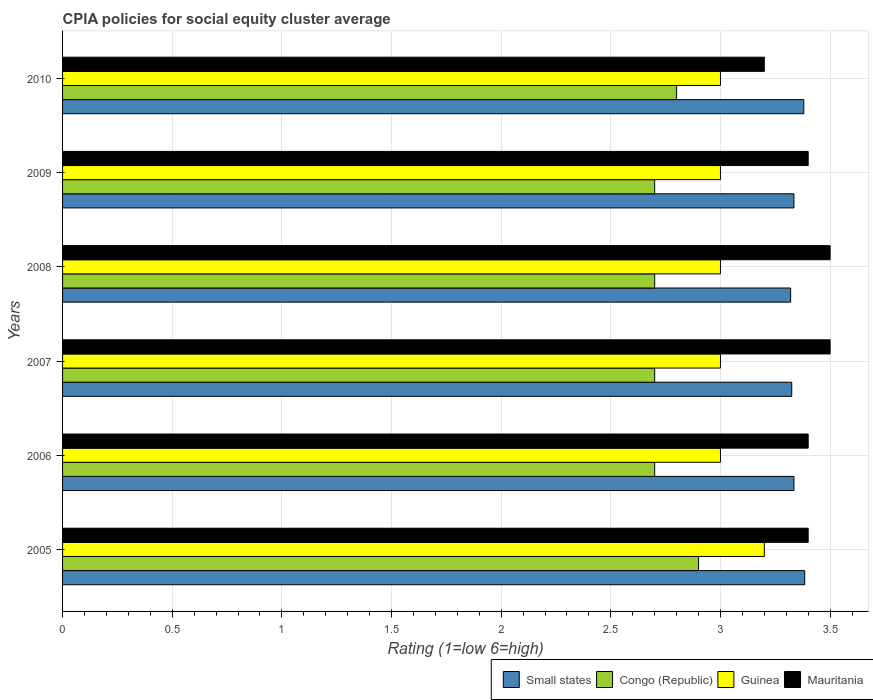How many groups of bars are there?
Give a very brief answer. 6. Are the number of bars per tick equal to the number of legend labels?
Keep it short and to the point. Yes. Are the number of bars on each tick of the Y-axis equal?
Provide a succinct answer. Yes. What is the CPIA rating in Guinea in 2006?
Provide a succinct answer. 3. Across all years, what is the maximum CPIA rating in Small states?
Offer a very short reply. 3.38. Across all years, what is the minimum CPIA rating in Small states?
Your answer should be compact. 3.32. In which year was the CPIA rating in Small states maximum?
Your answer should be compact. 2005. What is the total CPIA rating in Small states in the graph?
Your response must be concise. 20.08. What is the difference between the CPIA rating in Guinea in 2005 and that in 2006?
Make the answer very short. 0.2. What is the average CPIA rating in Congo (Republic) per year?
Keep it short and to the point. 2.75. In the year 2009, what is the difference between the CPIA rating in Guinea and CPIA rating in Congo (Republic)?
Provide a short and direct response. 0.3. What is the ratio of the CPIA rating in Small states in 2005 to that in 2010?
Offer a very short reply. 1. Is the CPIA rating in Small states in 2006 less than that in 2010?
Your response must be concise. Yes. What is the difference between the highest and the second highest CPIA rating in Mauritania?
Keep it short and to the point. 0. What is the difference between the highest and the lowest CPIA rating in Congo (Republic)?
Offer a terse response. 0.2. In how many years, is the CPIA rating in Congo (Republic) greater than the average CPIA rating in Congo (Republic) taken over all years?
Offer a terse response. 2. Is it the case that in every year, the sum of the CPIA rating in Small states and CPIA rating in Guinea is greater than the sum of CPIA rating in Mauritania and CPIA rating in Congo (Republic)?
Provide a succinct answer. Yes. What does the 2nd bar from the top in 2005 represents?
Make the answer very short. Guinea. What does the 3rd bar from the bottom in 2007 represents?
Ensure brevity in your answer.  Guinea. Are the values on the major ticks of X-axis written in scientific E-notation?
Offer a very short reply. No. Does the graph contain any zero values?
Make the answer very short. No. Does the graph contain grids?
Provide a succinct answer. Yes. Where does the legend appear in the graph?
Provide a short and direct response. Bottom right. How are the legend labels stacked?
Make the answer very short. Horizontal. What is the title of the graph?
Your response must be concise. CPIA policies for social equity cluster average. Does "Russian Federation" appear as one of the legend labels in the graph?
Provide a short and direct response. No. What is the label or title of the X-axis?
Keep it short and to the point. Rating (1=low 6=high). What is the Rating (1=low 6=high) of Small states in 2005?
Your answer should be very brief. 3.38. What is the Rating (1=low 6=high) in Congo (Republic) in 2005?
Provide a succinct answer. 2.9. What is the Rating (1=low 6=high) in Guinea in 2005?
Make the answer very short. 3.2. What is the Rating (1=low 6=high) of Mauritania in 2005?
Your answer should be very brief. 3.4. What is the Rating (1=low 6=high) of Small states in 2006?
Keep it short and to the point. 3.33. What is the Rating (1=low 6=high) in Guinea in 2006?
Offer a very short reply. 3. What is the Rating (1=low 6=high) in Small states in 2007?
Offer a very short reply. 3.33. What is the Rating (1=low 6=high) in Mauritania in 2007?
Your answer should be very brief. 3.5. What is the Rating (1=low 6=high) of Small states in 2008?
Offer a terse response. 3.32. What is the Rating (1=low 6=high) of Congo (Republic) in 2008?
Offer a very short reply. 2.7. What is the Rating (1=low 6=high) in Guinea in 2008?
Provide a short and direct response. 3. What is the Rating (1=low 6=high) of Mauritania in 2008?
Give a very brief answer. 3.5. What is the Rating (1=low 6=high) in Small states in 2009?
Provide a short and direct response. 3.33. What is the Rating (1=low 6=high) of Congo (Republic) in 2009?
Offer a very short reply. 2.7. What is the Rating (1=low 6=high) of Guinea in 2009?
Provide a succinct answer. 3. What is the Rating (1=low 6=high) of Mauritania in 2009?
Give a very brief answer. 3.4. What is the Rating (1=low 6=high) of Small states in 2010?
Ensure brevity in your answer.  3.38. Across all years, what is the maximum Rating (1=low 6=high) in Small states?
Your response must be concise. 3.38. Across all years, what is the minimum Rating (1=low 6=high) of Small states?
Your answer should be compact. 3.32. Across all years, what is the minimum Rating (1=low 6=high) in Guinea?
Give a very brief answer. 3. What is the total Rating (1=low 6=high) of Small states in the graph?
Your answer should be very brief. 20.08. What is the total Rating (1=low 6=high) of Congo (Republic) in the graph?
Provide a succinct answer. 16.5. What is the total Rating (1=low 6=high) in Mauritania in the graph?
Provide a short and direct response. 20.4. What is the difference between the Rating (1=low 6=high) in Small states in 2005 and that in 2006?
Offer a very short reply. 0.05. What is the difference between the Rating (1=low 6=high) in Congo (Republic) in 2005 and that in 2006?
Your answer should be very brief. 0.2. What is the difference between the Rating (1=low 6=high) of Small states in 2005 and that in 2007?
Ensure brevity in your answer.  0.06. What is the difference between the Rating (1=low 6=high) in Guinea in 2005 and that in 2007?
Your answer should be compact. 0.2. What is the difference between the Rating (1=low 6=high) of Mauritania in 2005 and that in 2007?
Your response must be concise. -0.1. What is the difference between the Rating (1=low 6=high) in Small states in 2005 and that in 2008?
Keep it short and to the point. 0.06. What is the difference between the Rating (1=low 6=high) of Congo (Republic) in 2005 and that in 2008?
Your answer should be compact. 0.2. What is the difference between the Rating (1=low 6=high) of Mauritania in 2005 and that in 2008?
Provide a succinct answer. -0.1. What is the difference between the Rating (1=low 6=high) in Small states in 2005 and that in 2009?
Make the answer very short. 0.05. What is the difference between the Rating (1=low 6=high) of Congo (Republic) in 2005 and that in 2009?
Your answer should be compact. 0.2. What is the difference between the Rating (1=low 6=high) of Mauritania in 2005 and that in 2009?
Keep it short and to the point. 0. What is the difference between the Rating (1=low 6=high) of Small states in 2005 and that in 2010?
Give a very brief answer. 0. What is the difference between the Rating (1=low 6=high) of Guinea in 2005 and that in 2010?
Keep it short and to the point. 0.2. What is the difference between the Rating (1=low 6=high) in Mauritania in 2005 and that in 2010?
Offer a very short reply. 0.2. What is the difference between the Rating (1=low 6=high) of Small states in 2006 and that in 2007?
Offer a very short reply. 0.01. What is the difference between the Rating (1=low 6=high) in Small states in 2006 and that in 2008?
Keep it short and to the point. 0.01. What is the difference between the Rating (1=low 6=high) in Guinea in 2006 and that in 2008?
Keep it short and to the point. 0. What is the difference between the Rating (1=low 6=high) of Small states in 2006 and that in 2009?
Ensure brevity in your answer.  0. What is the difference between the Rating (1=low 6=high) in Congo (Republic) in 2006 and that in 2009?
Make the answer very short. 0. What is the difference between the Rating (1=low 6=high) of Mauritania in 2006 and that in 2009?
Your response must be concise. 0. What is the difference between the Rating (1=low 6=high) in Small states in 2006 and that in 2010?
Your answer should be very brief. -0.04. What is the difference between the Rating (1=low 6=high) of Congo (Republic) in 2006 and that in 2010?
Ensure brevity in your answer.  -0.1. What is the difference between the Rating (1=low 6=high) in Guinea in 2006 and that in 2010?
Your answer should be compact. 0. What is the difference between the Rating (1=low 6=high) in Small states in 2007 and that in 2008?
Your answer should be very brief. 0.01. What is the difference between the Rating (1=low 6=high) in Mauritania in 2007 and that in 2008?
Your answer should be compact. 0. What is the difference between the Rating (1=low 6=high) of Small states in 2007 and that in 2009?
Provide a short and direct response. -0.01. What is the difference between the Rating (1=low 6=high) of Congo (Republic) in 2007 and that in 2009?
Your answer should be very brief. 0. What is the difference between the Rating (1=low 6=high) in Mauritania in 2007 and that in 2009?
Provide a short and direct response. 0.1. What is the difference between the Rating (1=low 6=high) of Small states in 2007 and that in 2010?
Ensure brevity in your answer.  -0.06. What is the difference between the Rating (1=low 6=high) in Congo (Republic) in 2007 and that in 2010?
Your response must be concise. -0.1. What is the difference between the Rating (1=low 6=high) of Guinea in 2007 and that in 2010?
Offer a very short reply. 0. What is the difference between the Rating (1=low 6=high) in Mauritania in 2007 and that in 2010?
Offer a terse response. 0.3. What is the difference between the Rating (1=low 6=high) of Small states in 2008 and that in 2009?
Ensure brevity in your answer.  -0.01. What is the difference between the Rating (1=low 6=high) of Congo (Republic) in 2008 and that in 2009?
Offer a very short reply. 0. What is the difference between the Rating (1=low 6=high) of Mauritania in 2008 and that in 2009?
Provide a succinct answer. 0.1. What is the difference between the Rating (1=low 6=high) in Small states in 2008 and that in 2010?
Provide a short and direct response. -0.06. What is the difference between the Rating (1=low 6=high) in Congo (Republic) in 2008 and that in 2010?
Provide a succinct answer. -0.1. What is the difference between the Rating (1=low 6=high) in Guinea in 2008 and that in 2010?
Make the answer very short. 0. What is the difference between the Rating (1=low 6=high) of Mauritania in 2008 and that in 2010?
Offer a terse response. 0.3. What is the difference between the Rating (1=low 6=high) in Small states in 2009 and that in 2010?
Give a very brief answer. -0.04. What is the difference between the Rating (1=low 6=high) of Congo (Republic) in 2009 and that in 2010?
Provide a succinct answer. -0.1. What is the difference between the Rating (1=low 6=high) in Guinea in 2009 and that in 2010?
Your answer should be compact. 0. What is the difference between the Rating (1=low 6=high) of Small states in 2005 and the Rating (1=low 6=high) of Congo (Republic) in 2006?
Ensure brevity in your answer.  0.68. What is the difference between the Rating (1=low 6=high) of Small states in 2005 and the Rating (1=low 6=high) of Guinea in 2006?
Your answer should be compact. 0.38. What is the difference between the Rating (1=low 6=high) of Small states in 2005 and the Rating (1=low 6=high) of Mauritania in 2006?
Offer a very short reply. -0.02. What is the difference between the Rating (1=low 6=high) in Congo (Republic) in 2005 and the Rating (1=low 6=high) in Guinea in 2006?
Your response must be concise. -0.1. What is the difference between the Rating (1=low 6=high) in Guinea in 2005 and the Rating (1=low 6=high) in Mauritania in 2006?
Give a very brief answer. -0.2. What is the difference between the Rating (1=low 6=high) of Small states in 2005 and the Rating (1=low 6=high) of Congo (Republic) in 2007?
Make the answer very short. 0.68. What is the difference between the Rating (1=low 6=high) of Small states in 2005 and the Rating (1=low 6=high) of Guinea in 2007?
Provide a short and direct response. 0.38. What is the difference between the Rating (1=low 6=high) in Small states in 2005 and the Rating (1=low 6=high) in Mauritania in 2007?
Offer a very short reply. -0.12. What is the difference between the Rating (1=low 6=high) in Congo (Republic) in 2005 and the Rating (1=low 6=high) in Guinea in 2007?
Give a very brief answer. -0.1. What is the difference between the Rating (1=low 6=high) of Guinea in 2005 and the Rating (1=low 6=high) of Mauritania in 2007?
Offer a very short reply. -0.3. What is the difference between the Rating (1=low 6=high) in Small states in 2005 and the Rating (1=low 6=high) in Congo (Republic) in 2008?
Offer a very short reply. 0.68. What is the difference between the Rating (1=low 6=high) of Small states in 2005 and the Rating (1=low 6=high) of Guinea in 2008?
Make the answer very short. 0.38. What is the difference between the Rating (1=low 6=high) of Small states in 2005 and the Rating (1=low 6=high) of Mauritania in 2008?
Ensure brevity in your answer.  -0.12. What is the difference between the Rating (1=low 6=high) in Congo (Republic) in 2005 and the Rating (1=low 6=high) in Guinea in 2008?
Your answer should be compact. -0.1. What is the difference between the Rating (1=low 6=high) of Guinea in 2005 and the Rating (1=low 6=high) of Mauritania in 2008?
Ensure brevity in your answer.  -0.3. What is the difference between the Rating (1=low 6=high) of Small states in 2005 and the Rating (1=low 6=high) of Congo (Republic) in 2009?
Your answer should be very brief. 0.68. What is the difference between the Rating (1=low 6=high) of Small states in 2005 and the Rating (1=low 6=high) of Guinea in 2009?
Your answer should be compact. 0.38. What is the difference between the Rating (1=low 6=high) of Small states in 2005 and the Rating (1=low 6=high) of Mauritania in 2009?
Your answer should be very brief. -0.02. What is the difference between the Rating (1=low 6=high) in Congo (Republic) in 2005 and the Rating (1=low 6=high) in Mauritania in 2009?
Provide a succinct answer. -0.5. What is the difference between the Rating (1=low 6=high) of Small states in 2005 and the Rating (1=low 6=high) of Congo (Republic) in 2010?
Your answer should be compact. 0.58. What is the difference between the Rating (1=low 6=high) of Small states in 2005 and the Rating (1=low 6=high) of Guinea in 2010?
Your answer should be compact. 0.38. What is the difference between the Rating (1=low 6=high) of Small states in 2005 and the Rating (1=low 6=high) of Mauritania in 2010?
Offer a terse response. 0.18. What is the difference between the Rating (1=low 6=high) of Congo (Republic) in 2005 and the Rating (1=low 6=high) of Guinea in 2010?
Your answer should be very brief. -0.1. What is the difference between the Rating (1=low 6=high) of Small states in 2006 and the Rating (1=low 6=high) of Congo (Republic) in 2007?
Make the answer very short. 0.64. What is the difference between the Rating (1=low 6=high) of Small states in 2006 and the Rating (1=low 6=high) of Guinea in 2007?
Ensure brevity in your answer.  0.34. What is the difference between the Rating (1=low 6=high) in Small states in 2006 and the Rating (1=low 6=high) in Mauritania in 2007?
Your answer should be compact. -0.17. What is the difference between the Rating (1=low 6=high) of Congo (Republic) in 2006 and the Rating (1=low 6=high) of Guinea in 2007?
Provide a short and direct response. -0.3. What is the difference between the Rating (1=low 6=high) of Congo (Republic) in 2006 and the Rating (1=low 6=high) of Mauritania in 2007?
Offer a terse response. -0.8. What is the difference between the Rating (1=low 6=high) of Small states in 2006 and the Rating (1=low 6=high) of Congo (Republic) in 2008?
Offer a terse response. 0.64. What is the difference between the Rating (1=low 6=high) of Small states in 2006 and the Rating (1=low 6=high) of Guinea in 2008?
Offer a terse response. 0.34. What is the difference between the Rating (1=low 6=high) of Small states in 2006 and the Rating (1=low 6=high) of Mauritania in 2008?
Your answer should be compact. -0.17. What is the difference between the Rating (1=low 6=high) of Congo (Republic) in 2006 and the Rating (1=low 6=high) of Mauritania in 2008?
Keep it short and to the point. -0.8. What is the difference between the Rating (1=low 6=high) of Guinea in 2006 and the Rating (1=low 6=high) of Mauritania in 2008?
Give a very brief answer. -0.5. What is the difference between the Rating (1=low 6=high) in Small states in 2006 and the Rating (1=low 6=high) in Congo (Republic) in 2009?
Ensure brevity in your answer.  0.64. What is the difference between the Rating (1=low 6=high) in Small states in 2006 and the Rating (1=low 6=high) in Guinea in 2009?
Provide a short and direct response. 0.34. What is the difference between the Rating (1=low 6=high) in Small states in 2006 and the Rating (1=low 6=high) in Mauritania in 2009?
Offer a terse response. -0.07. What is the difference between the Rating (1=low 6=high) of Congo (Republic) in 2006 and the Rating (1=low 6=high) of Mauritania in 2009?
Give a very brief answer. -0.7. What is the difference between the Rating (1=low 6=high) in Guinea in 2006 and the Rating (1=low 6=high) in Mauritania in 2009?
Your answer should be very brief. -0.4. What is the difference between the Rating (1=low 6=high) of Small states in 2006 and the Rating (1=low 6=high) of Congo (Republic) in 2010?
Keep it short and to the point. 0.54. What is the difference between the Rating (1=low 6=high) of Small states in 2006 and the Rating (1=low 6=high) of Guinea in 2010?
Provide a succinct answer. 0.34. What is the difference between the Rating (1=low 6=high) of Small states in 2006 and the Rating (1=low 6=high) of Mauritania in 2010?
Ensure brevity in your answer.  0.14. What is the difference between the Rating (1=low 6=high) in Congo (Republic) in 2006 and the Rating (1=low 6=high) in Guinea in 2010?
Make the answer very short. -0.3. What is the difference between the Rating (1=low 6=high) of Guinea in 2006 and the Rating (1=low 6=high) of Mauritania in 2010?
Provide a succinct answer. -0.2. What is the difference between the Rating (1=low 6=high) of Small states in 2007 and the Rating (1=low 6=high) of Congo (Republic) in 2008?
Offer a very short reply. 0.62. What is the difference between the Rating (1=low 6=high) in Small states in 2007 and the Rating (1=low 6=high) in Guinea in 2008?
Provide a succinct answer. 0.33. What is the difference between the Rating (1=low 6=high) of Small states in 2007 and the Rating (1=low 6=high) of Mauritania in 2008?
Give a very brief answer. -0.17. What is the difference between the Rating (1=low 6=high) of Congo (Republic) in 2007 and the Rating (1=low 6=high) of Guinea in 2008?
Make the answer very short. -0.3. What is the difference between the Rating (1=low 6=high) in Small states in 2007 and the Rating (1=low 6=high) in Congo (Republic) in 2009?
Your answer should be compact. 0.62. What is the difference between the Rating (1=low 6=high) of Small states in 2007 and the Rating (1=low 6=high) of Guinea in 2009?
Your response must be concise. 0.33. What is the difference between the Rating (1=low 6=high) of Small states in 2007 and the Rating (1=low 6=high) of Mauritania in 2009?
Make the answer very short. -0.07. What is the difference between the Rating (1=low 6=high) in Congo (Republic) in 2007 and the Rating (1=low 6=high) in Guinea in 2009?
Give a very brief answer. -0.3. What is the difference between the Rating (1=low 6=high) of Small states in 2007 and the Rating (1=low 6=high) of Congo (Republic) in 2010?
Your response must be concise. 0.53. What is the difference between the Rating (1=low 6=high) in Small states in 2007 and the Rating (1=low 6=high) in Guinea in 2010?
Offer a very short reply. 0.33. What is the difference between the Rating (1=low 6=high) of Small states in 2007 and the Rating (1=low 6=high) of Mauritania in 2010?
Offer a very short reply. 0.12. What is the difference between the Rating (1=low 6=high) in Congo (Republic) in 2007 and the Rating (1=low 6=high) in Guinea in 2010?
Provide a succinct answer. -0.3. What is the difference between the Rating (1=low 6=high) in Guinea in 2007 and the Rating (1=low 6=high) in Mauritania in 2010?
Provide a succinct answer. -0.2. What is the difference between the Rating (1=low 6=high) in Small states in 2008 and the Rating (1=low 6=high) in Congo (Republic) in 2009?
Make the answer very short. 0.62. What is the difference between the Rating (1=low 6=high) in Small states in 2008 and the Rating (1=low 6=high) in Guinea in 2009?
Provide a short and direct response. 0.32. What is the difference between the Rating (1=low 6=high) of Small states in 2008 and the Rating (1=low 6=high) of Mauritania in 2009?
Provide a short and direct response. -0.08. What is the difference between the Rating (1=low 6=high) of Congo (Republic) in 2008 and the Rating (1=low 6=high) of Guinea in 2009?
Make the answer very short. -0.3. What is the difference between the Rating (1=low 6=high) of Congo (Republic) in 2008 and the Rating (1=low 6=high) of Mauritania in 2009?
Make the answer very short. -0.7. What is the difference between the Rating (1=low 6=high) of Small states in 2008 and the Rating (1=low 6=high) of Congo (Republic) in 2010?
Provide a short and direct response. 0.52. What is the difference between the Rating (1=low 6=high) in Small states in 2008 and the Rating (1=low 6=high) in Guinea in 2010?
Provide a succinct answer. 0.32. What is the difference between the Rating (1=low 6=high) of Small states in 2008 and the Rating (1=low 6=high) of Mauritania in 2010?
Provide a succinct answer. 0.12. What is the difference between the Rating (1=low 6=high) of Small states in 2009 and the Rating (1=low 6=high) of Congo (Republic) in 2010?
Offer a terse response. 0.54. What is the difference between the Rating (1=low 6=high) in Small states in 2009 and the Rating (1=low 6=high) in Guinea in 2010?
Ensure brevity in your answer.  0.34. What is the difference between the Rating (1=low 6=high) in Small states in 2009 and the Rating (1=low 6=high) in Mauritania in 2010?
Ensure brevity in your answer.  0.14. What is the difference between the Rating (1=low 6=high) in Congo (Republic) in 2009 and the Rating (1=low 6=high) in Mauritania in 2010?
Ensure brevity in your answer.  -0.5. What is the difference between the Rating (1=low 6=high) in Guinea in 2009 and the Rating (1=low 6=high) in Mauritania in 2010?
Keep it short and to the point. -0.2. What is the average Rating (1=low 6=high) of Small states per year?
Provide a succinct answer. 3.35. What is the average Rating (1=low 6=high) of Congo (Republic) per year?
Your answer should be compact. 2.75. What is the average Rating (1=low 6=high) in Guinea per year?
Provide a short and direct response. 3.03. In the year 2005, what is the difference between the Rating (1=low 6=high) of Small states and Rating (1=low 6=high) of Congo (Republic)?
Provide a succinct answer. 0.48. In the year 2005, what is the difference between the Rating (1=low 6=high) of Small states and Rating (1=low 6=high) of Guinea?
Provide a short and direct response. 0.18. In the year 2005, what is the difference between the Rating (1=low 6=high) of Small states and Rating (1=low 6=high) of Mauritania?
Keep it short and to the point. -0.02. In the year 2005, what is the difference between the Rating (1=low 6=high) of Congo (Republic) and Rating (1=low 6=high) of Mauritania?
Offer a very short reply. -0.5. In the year 2006, what is the difference between the Rating (1=low 6=high) in Small states and Rating (1=low 6=high) in Congo (Republic)?
Provide a short and direct response. 0.64. In the year 2006, what is the difference between the Rating (1=low 6=high) of Small states and Rating (1=low 6=high) of Guinea?
Keep it short and to the point. 0.34. In the year 2006, what is the difference between the Rating (1=low 6=high) in Small states and Rating (1=low 6=high) in Mauritania?
Provide a succinct answer. -0.07. In the year 2006, what is the difference between the Rating (1=low 6=high) in Congo (Republic) and Rating (1=low 6=high) in Guinea?
Make the answer very short. -0.3. In the year 2006, what is the difference between the Rating (1=low 6=high) of Guinea and Rating (1=low 6=high) of Mauritania?
Ensure brevity in your answer.  -0.4. In the year 2007, what is the difference between the Rating (1=low 6=high) in Small states and Rating (1=low 6=high) in Congo (Republic)?
Keep it short and to the point. 0.62. In the year 2007, what is the difference between the Rating (1=low 6=high) of Small states and Rating (1=low 6=high) of Guinea?
Provide a short and direct response. 0.33. In the year 2007, what is the difference between the Rating (1=low 6=high) in Small states and Rating (1=low 6=high) in Mauritania?
Keep it short and to the point. -0.17. In the year 2008, what is the difference between the Rating (1=low 6=high) in Small states and Rating (1=low 6=high) in Congo (Republic)?
Give a very brief answer. 0.62. In the year 2008, what is the difference between the Rating (1=low 6=high) in Small states and Rating (1=low 6=high) in Guinea?
Offer a terse response. 0.32. In the year 2008, what is the difference between the Rating (1=low 6=high) of Small states and Rating (1=low 6=high) of Mauritania?
Your answer should be very brief. -0.18. In the year 2008, what is the difference between the Rating (1=low 6=high) in Guinea and Rating (1=low 6=high) in Mauritania?
Make the answer very short. -0.5. In the year 2009, what is the difference between the Rating (1=low 6=high) in Small states and Rating (1=low 6=high) in Congo (Republic)?
Your response must be concise. 0.64. In the year 2009, what is the difference between the Rating (1=low 6=high) of Small states and Rating (1=low 6=high) of Guinea?
Your response must be concise. 0.34. In the year 2009, what is the difference between the Rating (1=low 6=high) in Small states and Rating (1=low 6=high) in Mauritania?
Provide a short and direct response. -0.07. In the year 2009, what is the difference between the Rating (1=low 6=high) in Guinea and Rating (1=low 6=high) in Mauritania?
Offer a terse response. -0.4. In the year 2010, what is the difference between the Rating (1=low 6=high) in Small states and Rating (1=low 6=high) in Congo (Republic)?
Ensure brevity in your answer.  0.58. In the year 2010, what is the difference between the Rating (1=low 6=high) of Small states and Rating (1=low 6=high) of Guinea?
Make the answer very short. 0.38. In the year 2010, what is the difference between the Rating (1=low 6=high) of Small states and Rating (1=low 6=high) of Mauritania?
Ensure brevity in your answer.  0.18. In the year 2010, what is the difference between the Rating (1=low 6=high) in Congo (Republic) and Rating (1=low 6=high) in Guinea?
Your answer should be compact. -0.2. In the year 2010, what is the difference between the Rating (1=low 6=high) of Congo (Republic) and Rating (1=low 6=high) of Mauritania?
Your answer should be very brief. -0.4. In the year 2010, what is the difference between the Rating (1=low 6=high) in Guinea and Rating (1=low 6=high) in Mauritania?
Give a very brief answer. -0.2. What is the ratio of the Rating (1=low 6=high) in Small states in 2005 to that in 2006?
Offer a terse response. 1.01. What is the ratio of the Rating (1=low 6=high) of Congo (Republic) in 2005 to that in 2006?
Ensure brevity in your answer.  1.07. What is the ratio of the Rating (1=low 6=high) in Guinea in 2005 to that in 2006?
Keep it short and to the point. 1.07. What is the ratio of the Rating (1=low 6=high) of Mauritania in 2005 to that in 2006?
Give a very brief answer. 1. What is the ratio of the Rating (1=low 6=high) of Small states in 2005 to that in 2007?
Make the answer very short. 1.02. What is the ratio of the Rating (1=low 6=high) of Congo (Republic) in 2005 to that in 2007?
Offer a very short reply. 1.07. What is the ratio of the Rating (1=low 6=high) of Guinea in 2005 to that in 2007?
Offer a very short reply. 1.07. What is the ratio of the Rating (1=low 6=high) in Mauritania in 2005 to that in 2007?
Your answer should be compact. 0.97. What is the ratio of the Rating (1=low 6=high) of Small states in 2005 to that in 2008?
Provide a succinct answer. 1.02. What is the ratio of the Rating (1=low 6=high) of Congo (Republic) in 2005 to that in 2008?
Your answer should be very brief. 1.07. What is the ratio of the Rating (1=low 6=high) in Guinea in 2005 to that in 2008?
Offer a terse response. 1.07. What is the ratio of the Rating (1=low 6=high) in Mauritania in 2005 to that in 2008?
Provide a short and direct response. 0.97. What is the ratio of the Rating (1=low 6=high) in Small states in 2005 to that in 2009?
Make the answer very short. 1.01. What is the ratio of the Rating (1=low 6=high) in Congo (Republic) in 2005 to that in 2009?
Give a very brief answer. 1.07. What is the ratio of the Rating (1=low 6=high) of Guinea in 2005 to that in 2009?
Provide a succinct answer. 1.07. What is the ratio of the Rating (1=low 6=high) in Mauritania in 2005 to that in 2009?
Your response must be concise. 1. What is the ratio of the Rating (1=low 6=high) of Small states in 2005 to that in 2010?
Ensure brevity in your answer.  1. What is the ratio of the Rating (1=low 6=high) in Congo (Republic) in 2005 to that in 2010?
Give a very brief answer. 1.04. What is the ratio of the Rating (1=low 6=high) in Guinea in 2005 to that in 2010?
Give a very brief answer. 1.07. What is the ratio of the Rating (1=low 6=high) of Mauritania in 2005 to that in 2010?
Offer a very short reply. 1.06. What is the ratio of the Rating (1=low 6=high) of Mauritania in 2006 to that in 2007?
Keep it short and to the point. 0.97. What is the ratio of the Rating (1=low 6=high) of Congo (Republic) in 2006 to that in 2008?
Keep it short and to the point. 1. What is the ratio of the Rating (1=low 6=high) of Guinea in 2006 to that in 2008?
Make the answer very short. 1. What is the ratio of the Rating (1=low 6=high) in Mauritania in 2006 to that in 2008?
Make the answer very short. 0.97. What is the ratio of the Rating (1=low 6=high) in Small states in 2006 to that in 2009?
Your answer should be very brief. 1. What is the ratio of the Rating (1=low 6=high) of Congo (Republic) in 2006 to that in 2009?
Offer a terse response. 1. What is the ratio of the Rating (1=low 6=high) in Guinea in 2006 to that in 2009?
Offer a very short reply. 1. What is the ratio of the Rating (1=low 6=high) of Mauritania in 2006 to that in 2009?
Make the answer very short. 1. What is the ratio of the Rating (1=low 6=high) of Small states in 2006 to that in 2010?
Keep it short and to the point. 0.99. What is the ratio of the Rating (1=low 6=high) of Congo (Republic) in 2006 to that in 2010?
Keep it short and to the point. 0.96. What is the ratio of the Rating (1=low 6=high) of Guinea in 2006 to that in 2010?
Keep it short and to the point. 1. What is the ratio of the Rating (1=low 6=high) of Small states in 2007 to that in 2008?
Your response must be concise. 1. What is the ratio of the Rating (1=low 6=high) of Congo (Republic) in 2007 to that in 2008?
Your answer should be very brief. 1. What is the ratio of the Rating (1=low 6=high) of Mauritania in 2007 to that in 2009?
Give a very brief answer. 1.03. What is the ratio of the Rating (1=low 6=high) in Small states in 2007 to that in 2010?
Your answer should be compact. 0.98. What is the ratio of the Rating (1=low 6=high) in Congo (Republic) in 2007 to that in 2010?
Give a very brief answer. 0.96. What is the ratio of the Rating (1=low 6=high) in Mauritania in 2007 to that in 2010?
Your response must be concise. 1.09. What is the ratio of the Rating (1=low 6=high) of Small states in 2008 to that in 2009?
Keep it short and to the point. 1. What is the ratio of the Rating (1=low 6=high) in Congo (Republic) in 2008 to that in 2009?
Give a very brief answer. 1. What is the ratio of the Rating (1=low 6=high) in Mauritania in 2008 to that in 2009?
Provide a succinct answer. 1.03. What is the ratio of the Rating (1=low 6=high) of Small states in 2008 to that in 2010?
Offer a terse response. 0.98. What is the ratio of the Rating (1=low 6=high) of Congo (Republic) in 2008 to that in 2010?
Make the answer very short. 0.96. What is the ratio of the Rating (1=low 6=high) in Guinea in 2008 to that in 2010?
Offer a terse response. 1. What is the ratio of the Rating (1=low 6=high) of Mauritania in 2008 to that in 2010?
Your response must be concise. 1.09. What is the ratio of the Rating (1=low 6=high) in Small states in 2009 to that in 2010?
Your response must be concise. 0.99. What is the ratio of the Rating (1=low 6=high) in Congo (Republic) in 2009 to that in 2010?
Provide a short and direct response. 0.96. What is the ratio of the Rating (1=low 6=high) in Guinea in 2009 to that in 2010?
Provide a succinct answer. 1. What is the ratio of the Rating (1=low 6=high) in Mauritania in 2009 to that in 2010?
Provide a short and direct response. 1.06. What is the difference between the highest and the second highest Rating (1=low 6=high) in Small states?
Provide a short and direct response. 0. What is the difference between the highest and the second highest Rating (1=low 6=high) of Congo (Republic)?
Ensure brevity in your answer.  0.1. What is the difference between the highest and the second highest Rating (1=low 6=high) in Guinea?
Your response must be concise. 0.2. What is the difference between the highest and the second highest Rating (1=low 6=high) in Mauritania?
Your answer should be very brief. 0. What is the difference between the highest and the lowest Rating (1=low 6=high) of Small states?
Provide a short and direct response. 0.06. What is the difference between the highest and the lowest Rating (1=low 6=high) in Guinea?
Offer a terse response. 0.2. What is the difference between the highest and the lowest Rating (1=low 6=high) of Mauritania?
Your answer should be very brief. 0.3. 